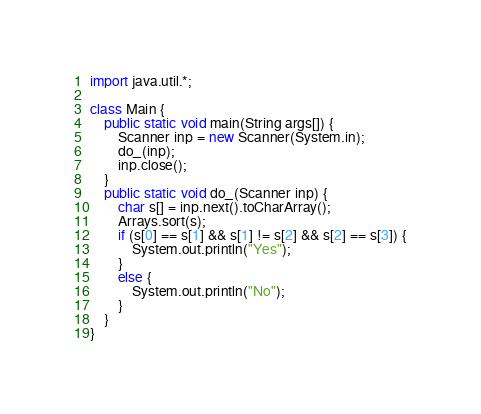Convert code to text. <code><loc_0><loc_0><loc_500><loc_500><_Java_>import java.util.*;

class Main {
    public static void main(String args[]) {
        Scanner inp = new Scanner(System.in);
        do_(inp);
        inp.close();
    }
    public static void do_(Scanner inp) {
        char s[] = inp.next().toCharArray();
        Arrays.sort(s);
        if (s[0] == s[1] && s[1] != s[2] && s[2] == s[3]) {
            System.out.println("Yes");
        }
        else {
            System.out.println("No");
        }
    }
}
</code> 